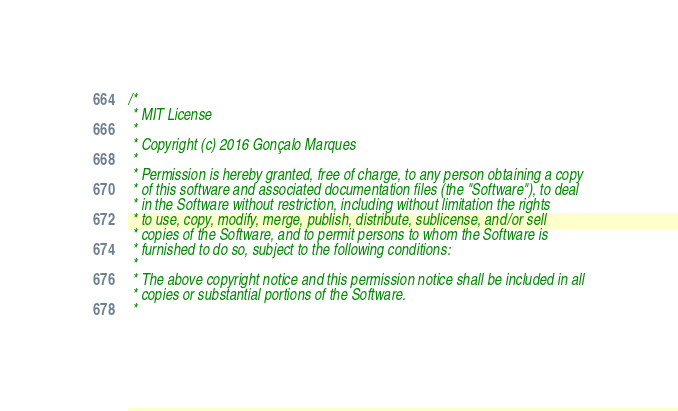<code> <loc_0><loc_0><loc_500><loc_500><_Scala_>/*
 * MIT License
 *
 * Copyright (c) 2016 Gonçalo Marques
 *
 * Permission is hereby granted, free of charge, to any person obtaining a copy
 * of this software and associated documentation files (the "Software"), to deal
 * in the Software without restriction, including without limitation the rights
 * to use, copy, modify, merge, publish, distribute, sublicense, and/or sell
 * copies of the Software, and to permit persons to whom the Software is
 * furnished to do so, subject to the following conditions:
 *
 * The above copyright notice and this permission notice shall be included in all
 * copies or substantial portions of the Software.
 *</code> 